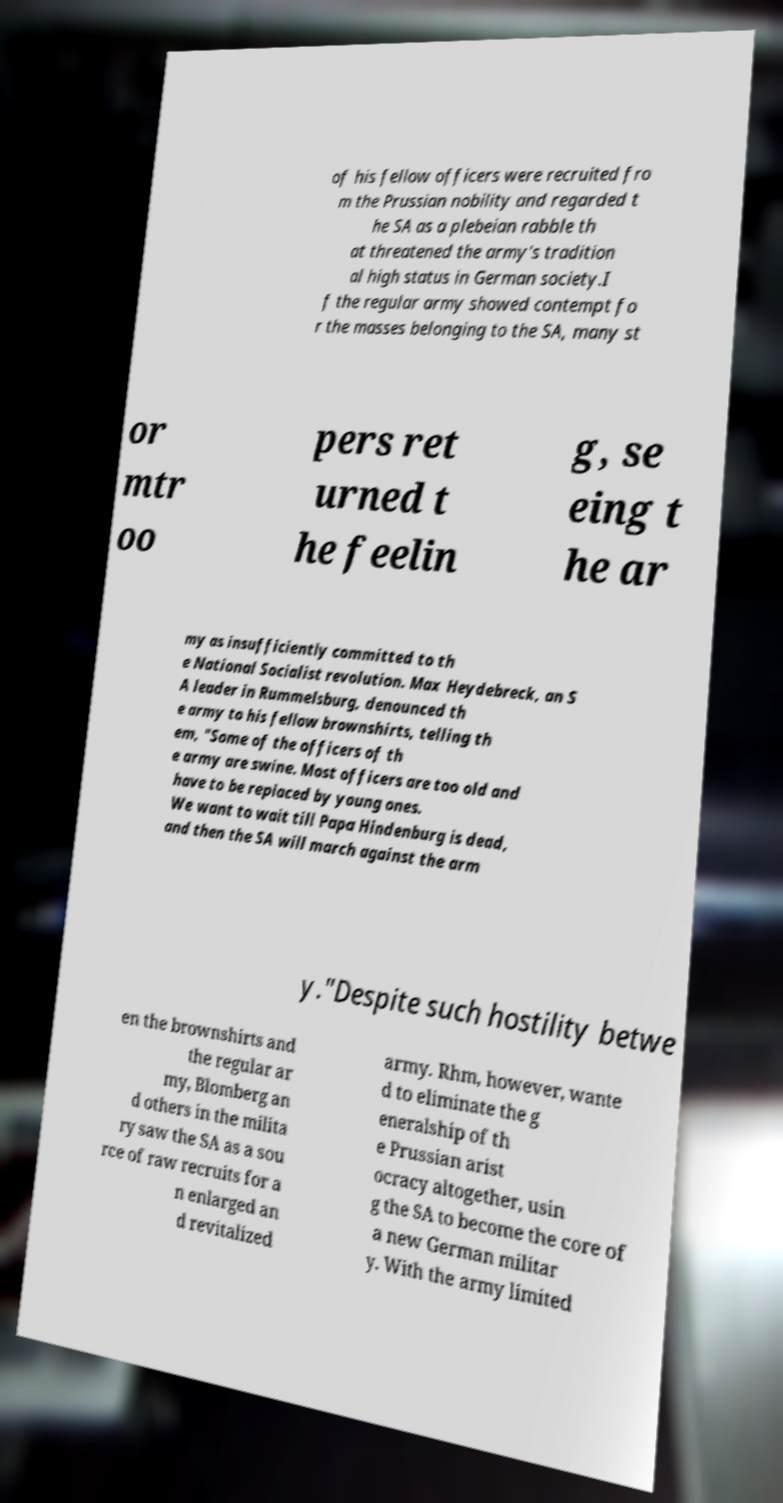Please read and relay the text visible in this image. What does it say? of his fellow officers were recruited fro m the Prussian nobility and regarded t he SA as a plebeian rabble th at threatened the army's tradition al high status in German society.I f the regular army showed contempt fo r the masses belonging to the SA, many st or mtr oo pers ret urned t he feelin g, se eing t he ar my as insufficiently committed to th e National Socialist revolution. Max Heydebreck, an S A leader in Rummelsburg, denounced th e army to his fellow brownshirts, telling th em, "Some of the officers of th e army are swine. Most officers are too old and have to be replaced by young ones. We want to wait till Papa Hindenburg is dead, and then the SA will march against the arm y."Despite such hostility betwe en the brownshirts and the regular ar my, Blomberg an d others in the milita ry saw the SA as a sou rce of raw recruits for a n enlarged an d revitalized army. Rhm, however, wante d to eliminate the g eneralship of th e Prussian arist ocracy altogether, usin g the SA to become the core of a new German militar y. With the army limited 